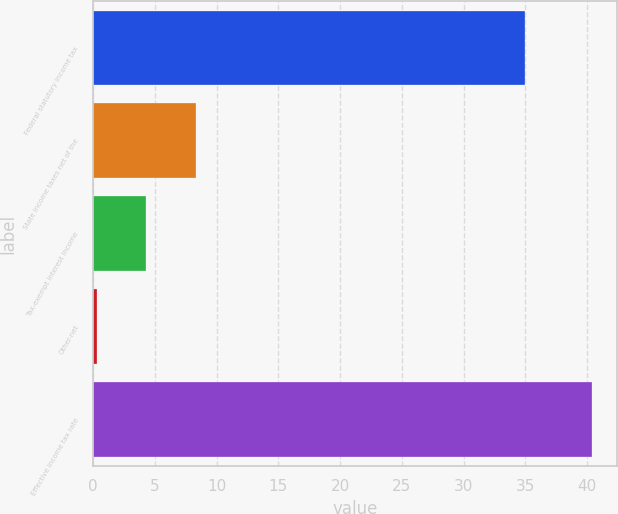Convert chart to OTSL. <chart><loc_0><loc_0><loc_500><loc_500><bar_chart><fcel>Federal statutory income tax<fcel>State income taxes net of the<fcel>Tax-exempt interest income<fcel>Other-net<fcel>Effective income tax rate<nl><fcel>35<fcel>8.32<fcel>4.31<fcel>0.3<fcel>40.4<nl></chart> 